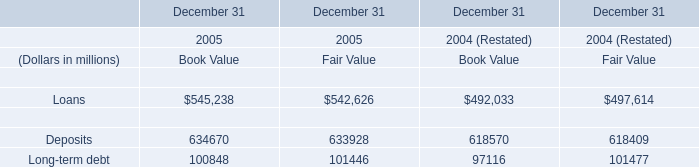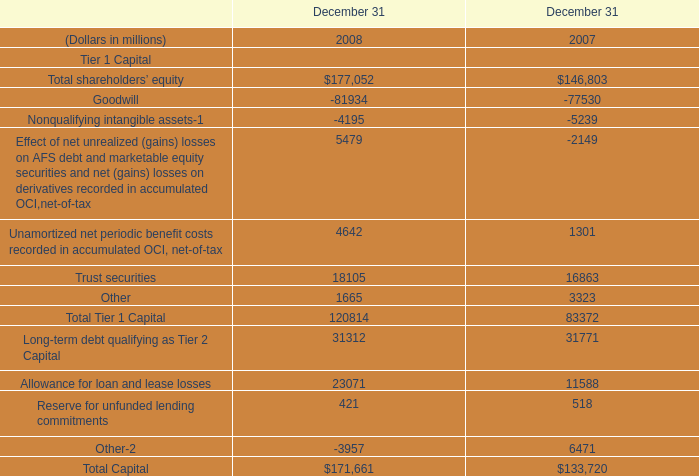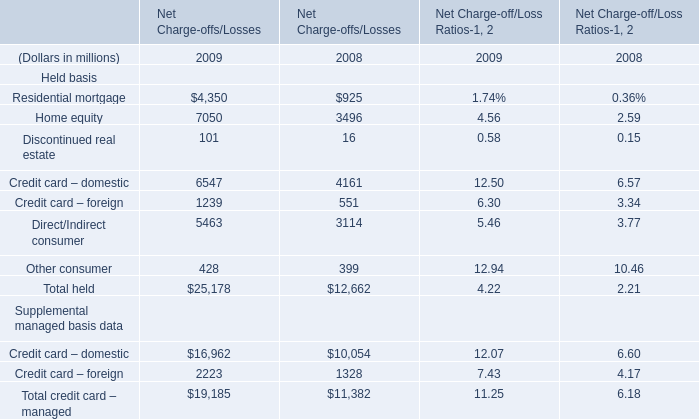What's the difference of Residential mortgage between 2009 and 2008? (in million) 
Computations: (4350 - 925)
Answer: 3425.0. 